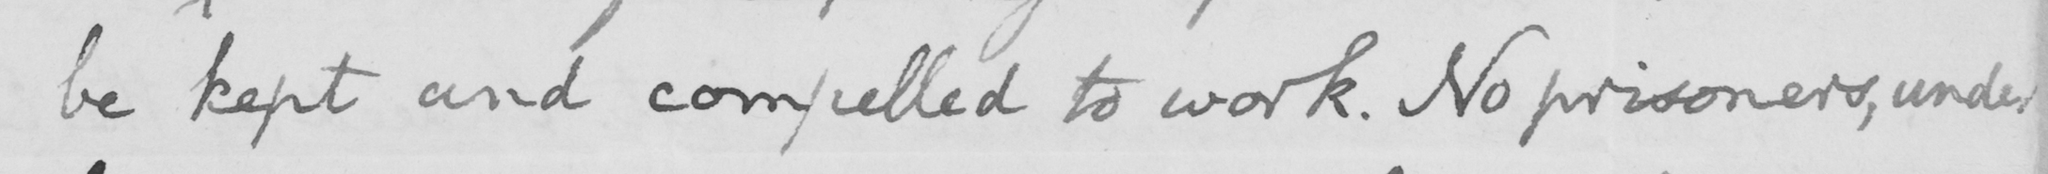What text is written in this handwritten line? be kept and compelled to work. No prisoners, under 